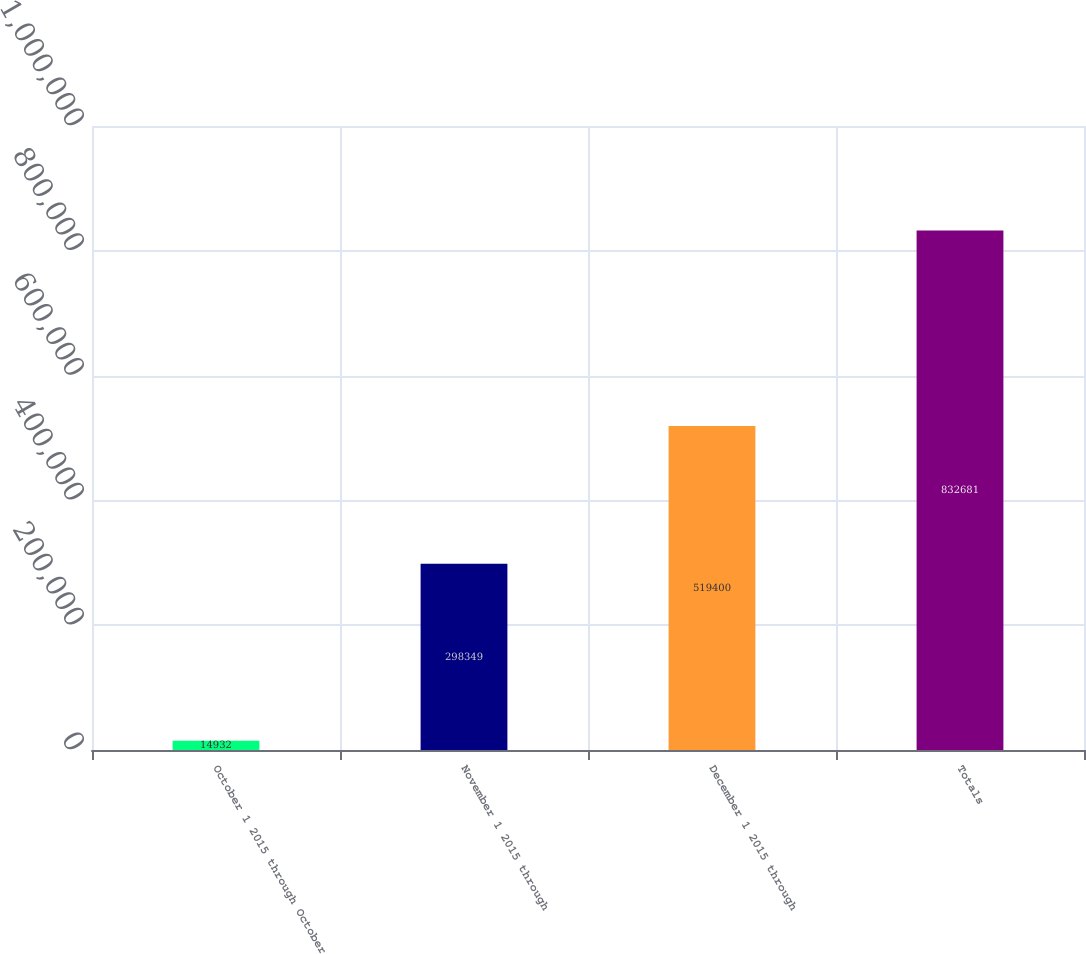<chart> <loc_0><loc_0><loc_500><loc_500><bar_chart><fcel>October 1 2015 through October<fcel>November 1 2015 through<fcel>December 1 2015 through<fcel>Totals<nl><fcel>14932<fcel>298349<fcel>519400<fcel>832681<nl></chart> 